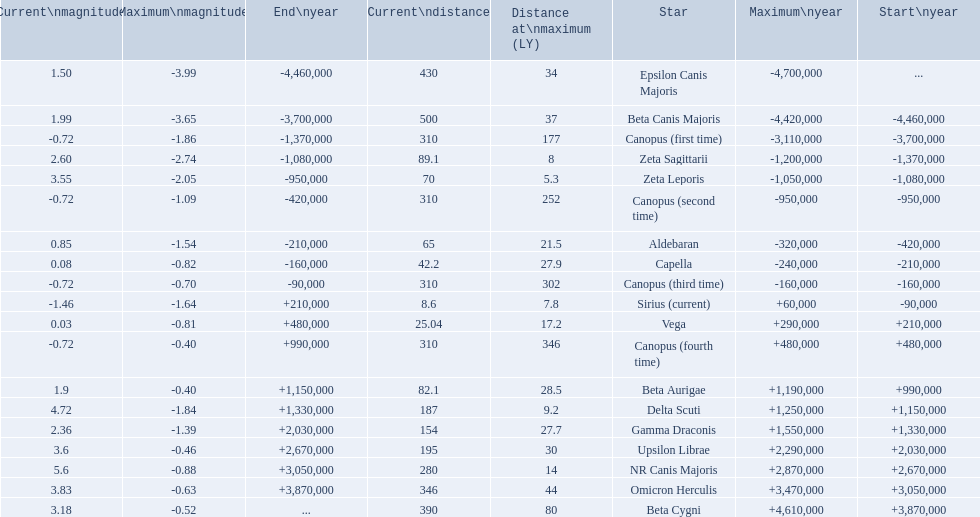What star has a a maximum magnitude of -0.63. Omicron Herculis. What star has a current distance of 390? Beta Cygni. 